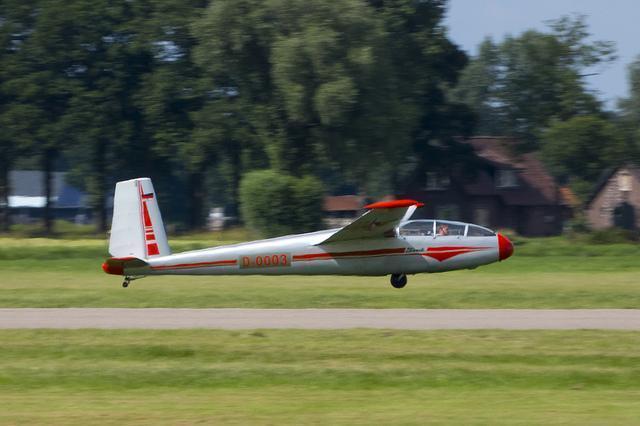How many wheels are on this plane?
Give a very brief answer. 2. 